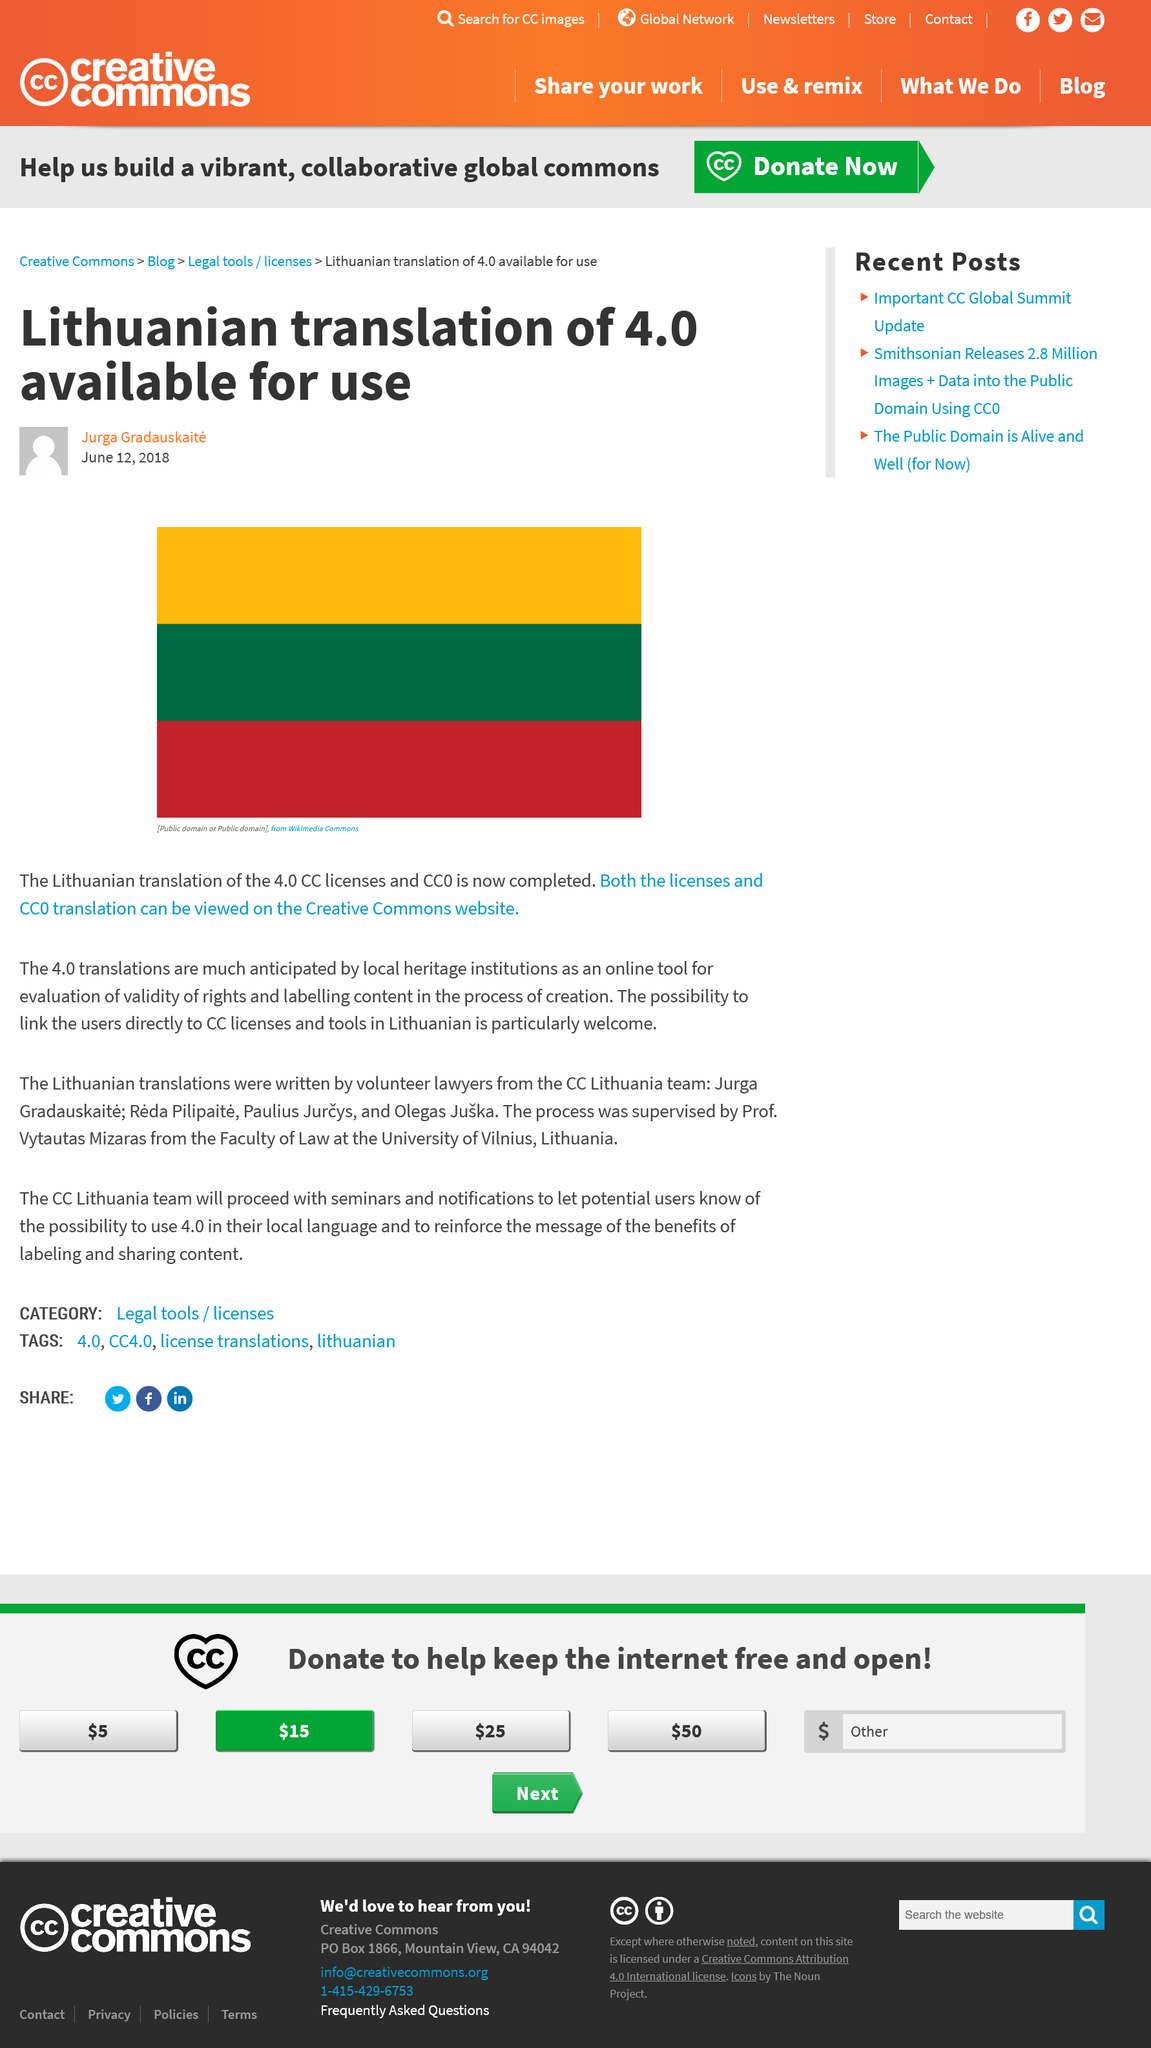Identify some key points in this picture. It is particularly welcome that users in Lithuania can now be linked to licenses and tools. This provides a convenient and accessible way for users to access the resources they need to effectively use the software. The online tool is welcomed by the local heritage institutions in Lithuania, including those that are institutions that offer online courses. The translation of CC licenses version 4.0 into Lithuanian was completed. 